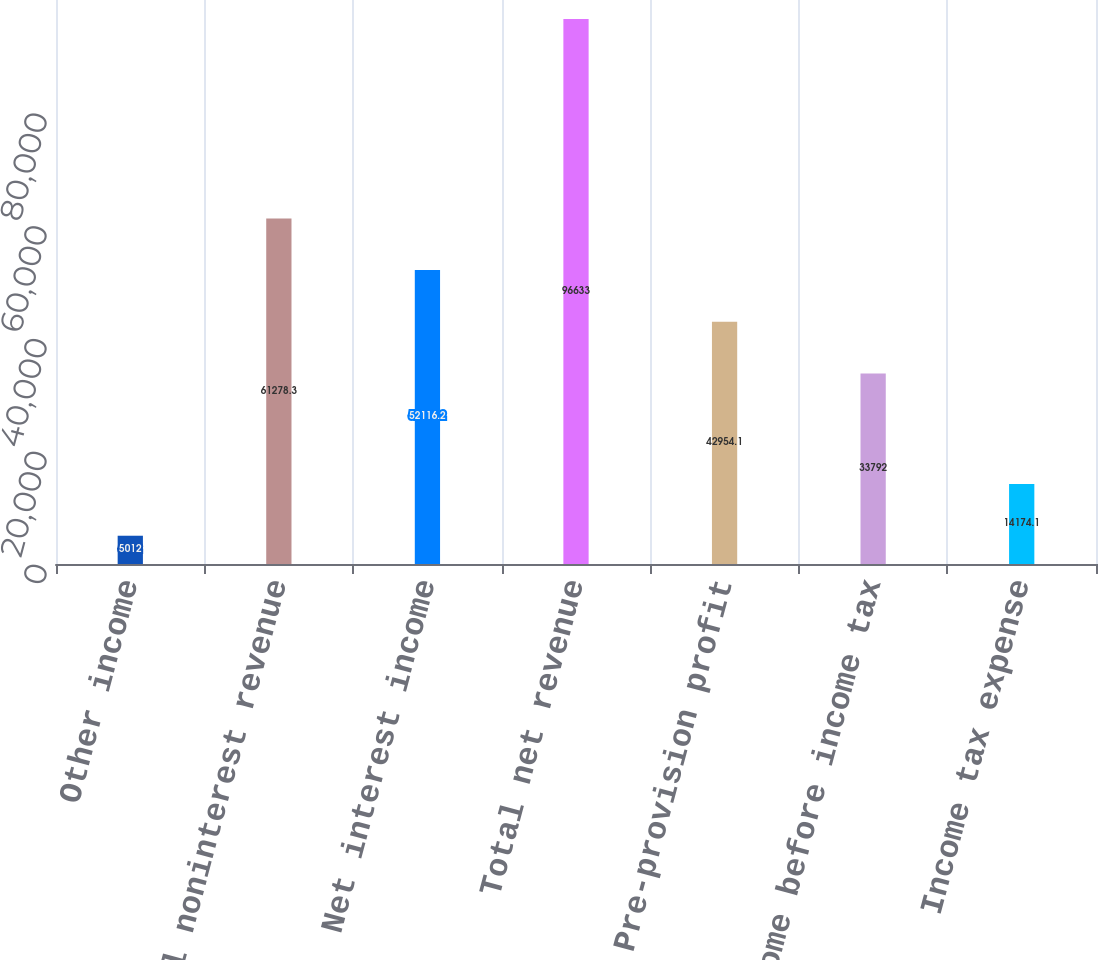Convert chart to OTSL. <chart><loc_0><loc_0><loc_500><loc_500><bar_chart><fcel>Other income<fcel>Total noninterest revenue<fcel>Net interest income<fcel>Total net revenue<fcel>Pre-provision profit<fcel>Income before income tax<fcel>Income tax expense<nl><fcel>5012<fcel>61278.3<fcel>52116.2<fcel>96633<fcel>42954.1<fcel>33792<fcel>14174.1<nl></chart> 